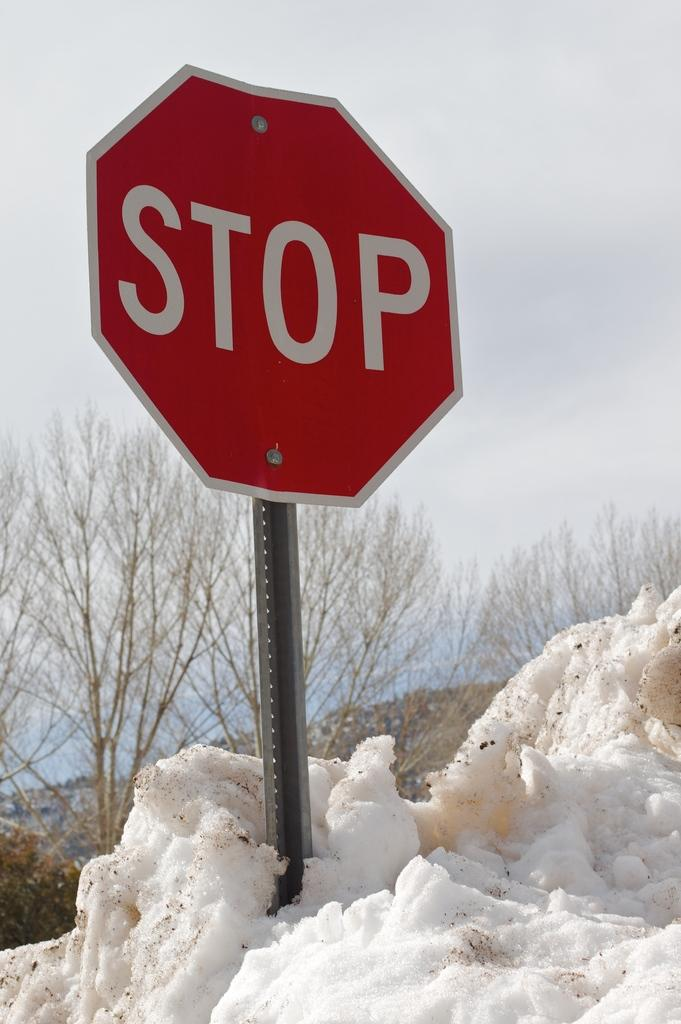<image>
Write a terse but informative summary of the picture. The stop sign is almost buried in the snow. 